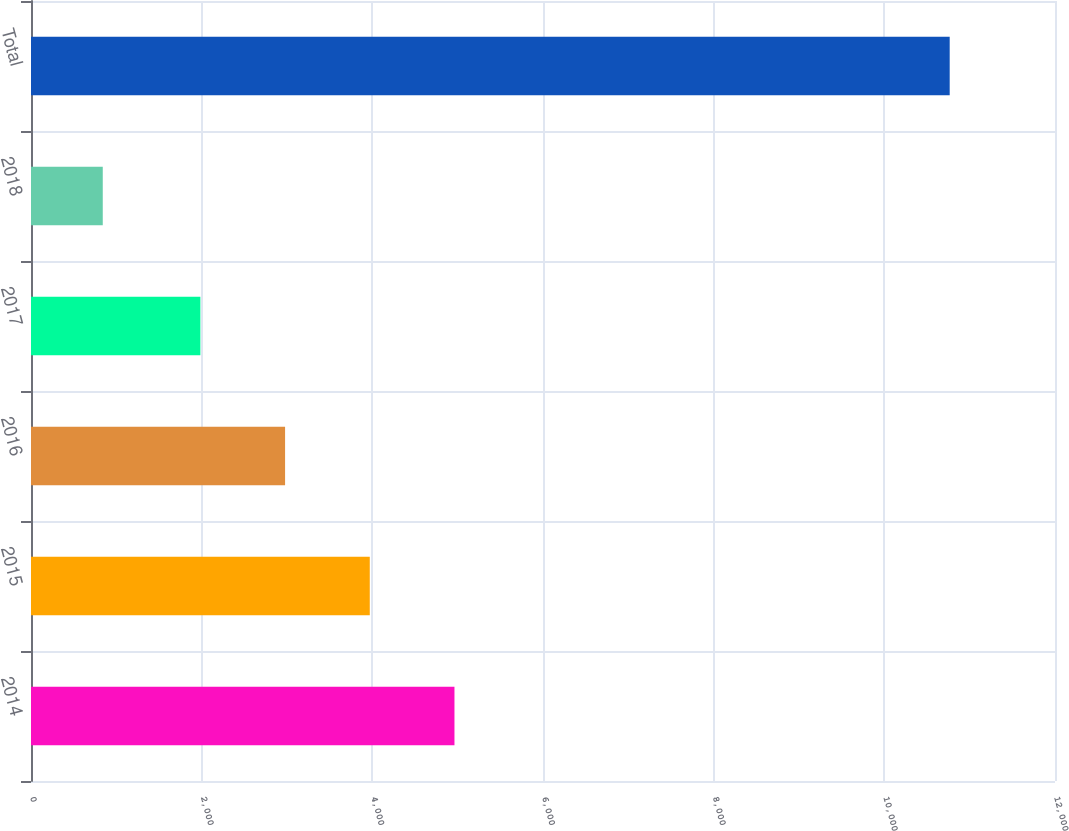<chart> <loc_0><loc_0><loc_500><loc_500><bar_chart><fcel>2014<fcel>2015<fcel>2016<fcel>2017<fcel>2018<fcel>Total<nl><fcel>4962.5<fcel>3970<fcel>2977.5<fcel>1985<fcel>841<fcel>10766<nl></chart> 